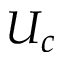Convert formula to latex. <formula><loc_0><loc_0><loc_500><loc_500>U _ { c }</formula> 